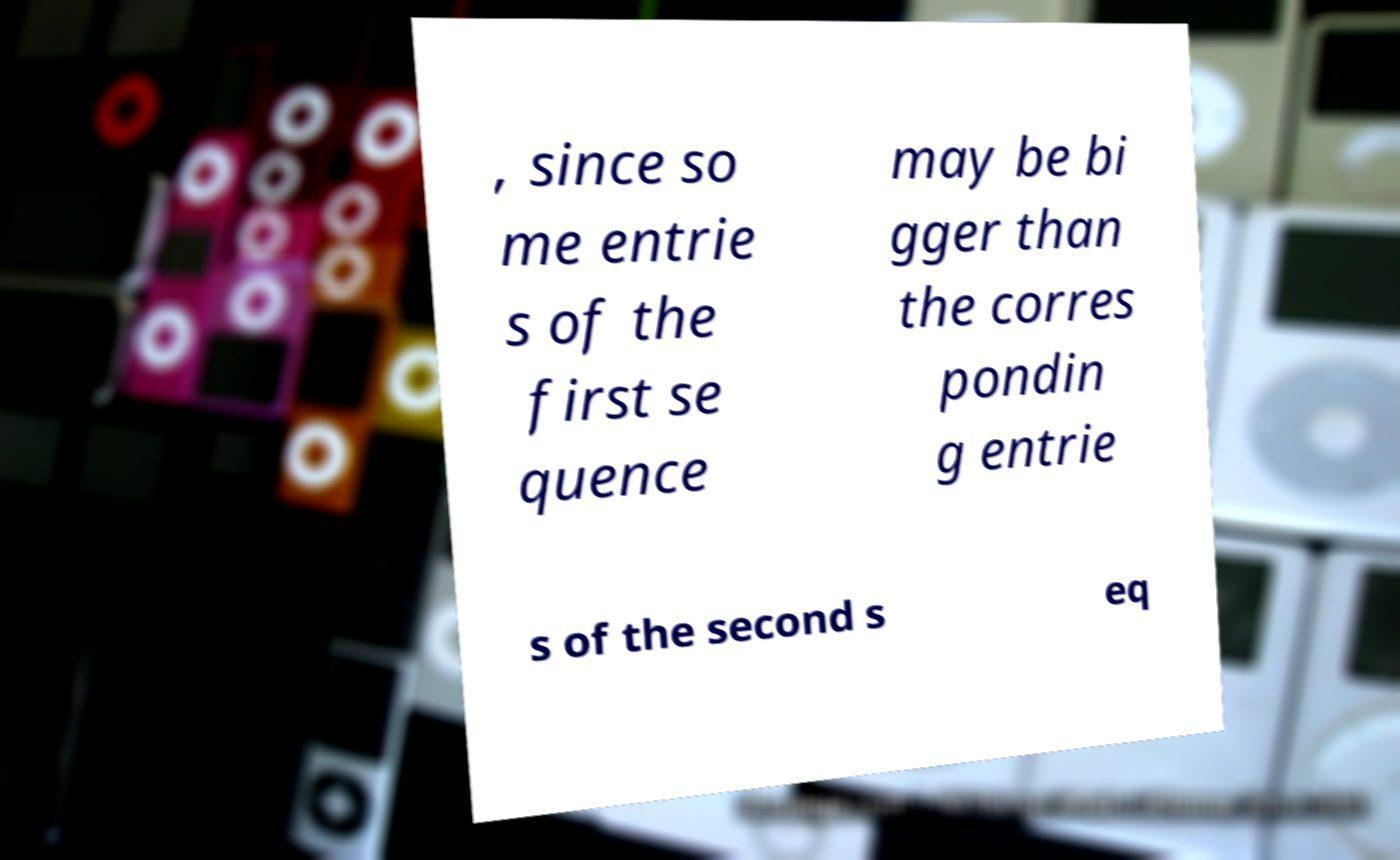There's text embedded in this image that I need extracted. Can you transcribe it verbatim? , since so me entrie s of the first se quence may be bi gger than the corres pondin g entrie s of the second s eq 